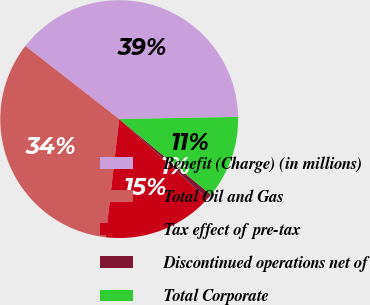<chart> <loc_0><loc_0><loc_500><loc_500><pie_chart><fcel>Benefit (Charge) (in millions)<fcel>Total Oil and Gas<fcel>Tax effect of pre-tax<fcel>Discontinued operations net of<fcel>Total Corporate<nl><fcel>39.18%<fcel>33.71%<fcel>15.12%<fcel>0.72%<fcel>11.27%<nl></chart> 